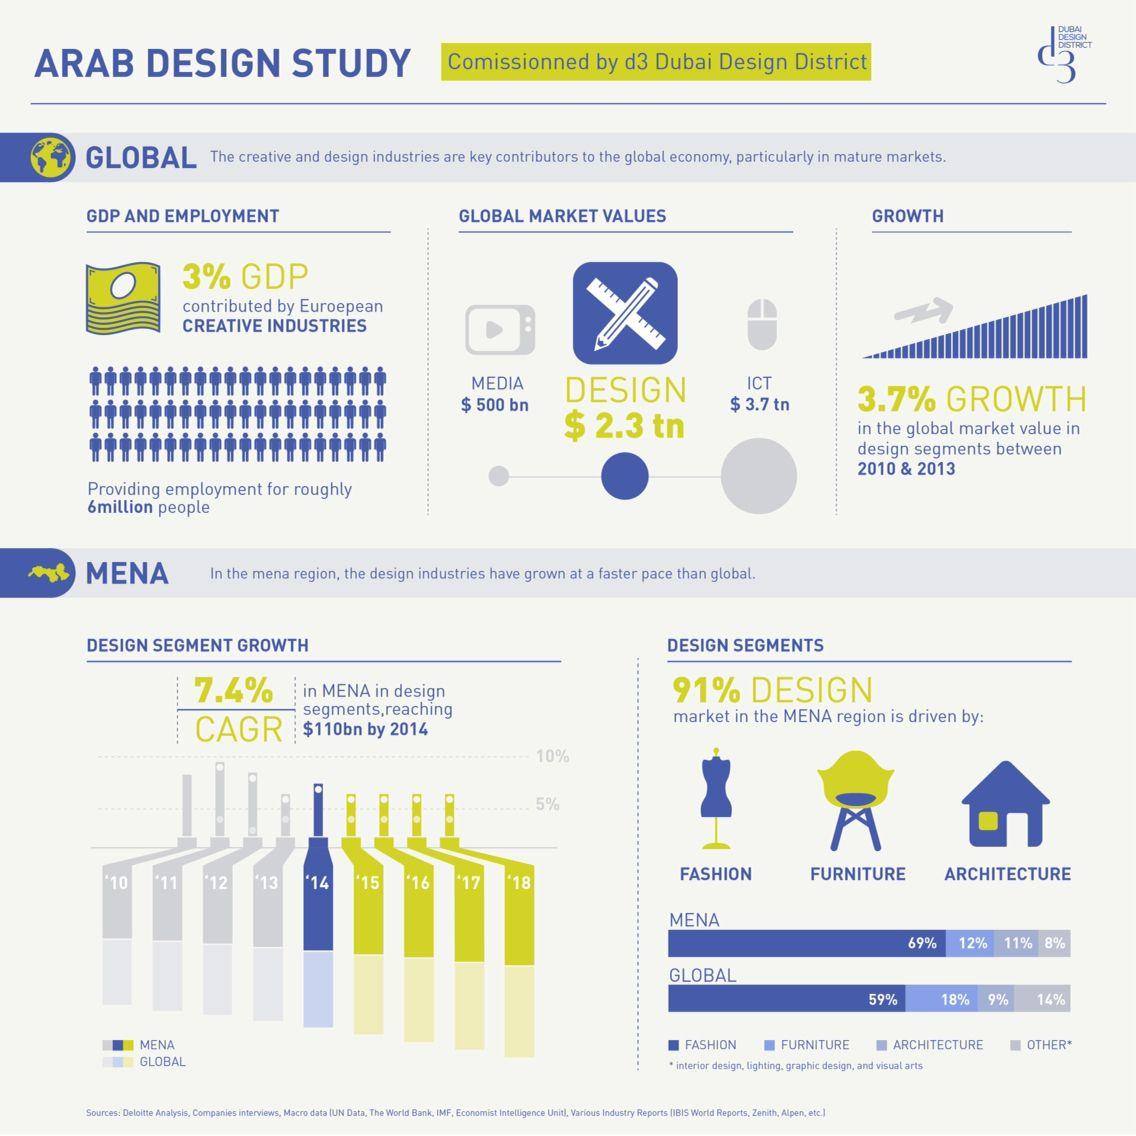Identify some key points in this picture. The global market value for design services is estimated to be approximately $2.3 trillion. According to recent global market data, architecture drives just 9% of the design market. According to recent data, the fashion industry accounts for 69% of the design market in the MENA region. According to recent statistics, architecture accounts for only 11% of the design market in the MENA region. The global market value for media services is estimated to be $500 billion. 